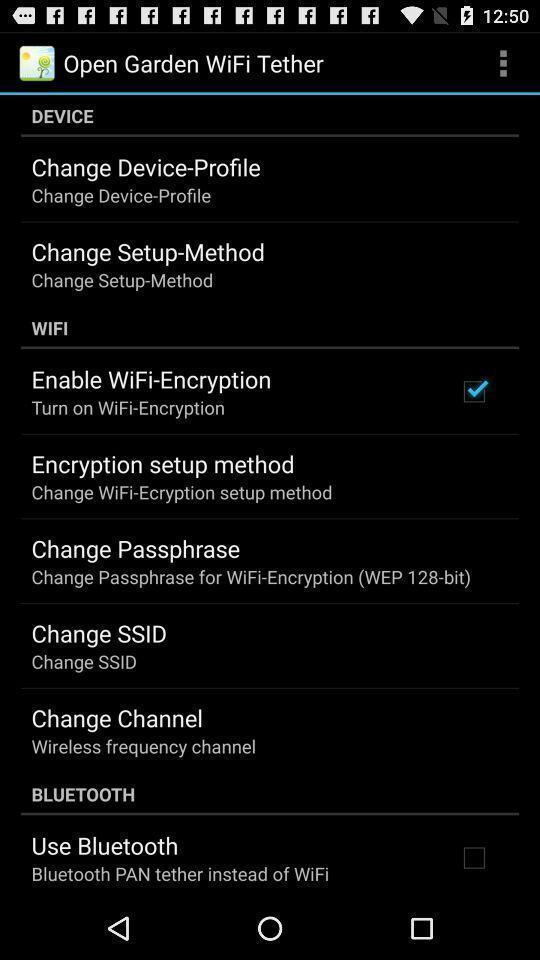Describe this image in words. Page showing different options about wifi. 